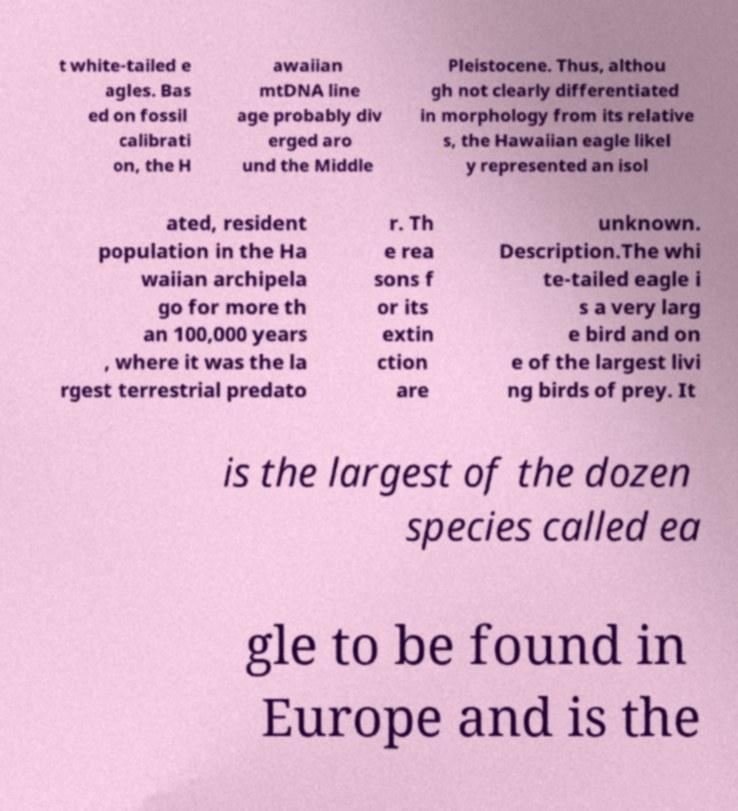Could you assist in decoding the text presented in this image and type it out clearly? t white-tailed e agles. Bas ed on fossil calibrati on, the H awaiian mtDNA line age probably div erged aro und the Middle Pleistocene. Thus, althou gh not clearly differentiated in morphology from its relative s, the Hawaiian eagle likel y represented an isol ated, resident population in the Ha waiian archipela go for more th an 100,000 years , where it was the la rgest terrestrial predato r. Th e rea sons f or its extin ction are unknown. Description.The whi te-tailed eagle i s a very larg e bird and on e of the largest livi ng birds of prey. It is the largest of the dozen species called ea gle to be found in Europe and is the 